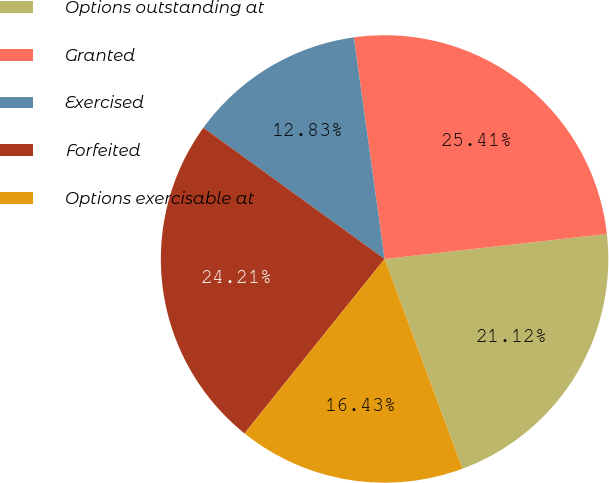Convert chart to OTSL. <chart><loc_0><loc_0><loc_500><loc_500><pie_chart><fcel>Options outstanding at<fcel>Granted<fcel>Exercised<fcel>Forfeited<fcel>Options exercisable at<nl><fcel>21.12%<fcel>25.41%<fcel>12.83%<fcel>24.21%<fcel>16.43%<nl></chart> 